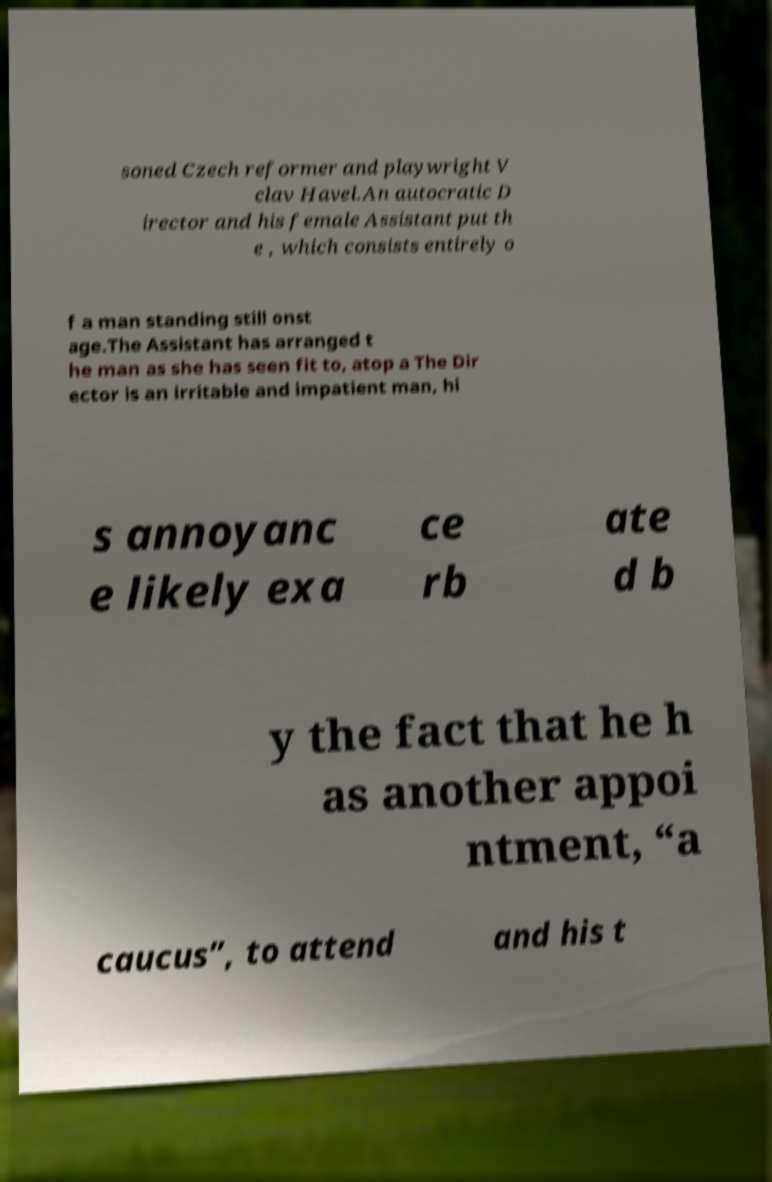Can you accurately transcribe the text from the provided image for me? soned Czech reformer and playwright V clav Havel.An autocratic D irector and his female Assistant put th e , which consists entirely o f a man standing still onst age.The Assistant has arranged t he man as she has seen fit to, atop a The Dir ector is an irritable and impatient man, hi s annoyanc e likely exa ce rb ate d b y the fact that he h as another appoi ntment, “a caucus”, to attend and his t 